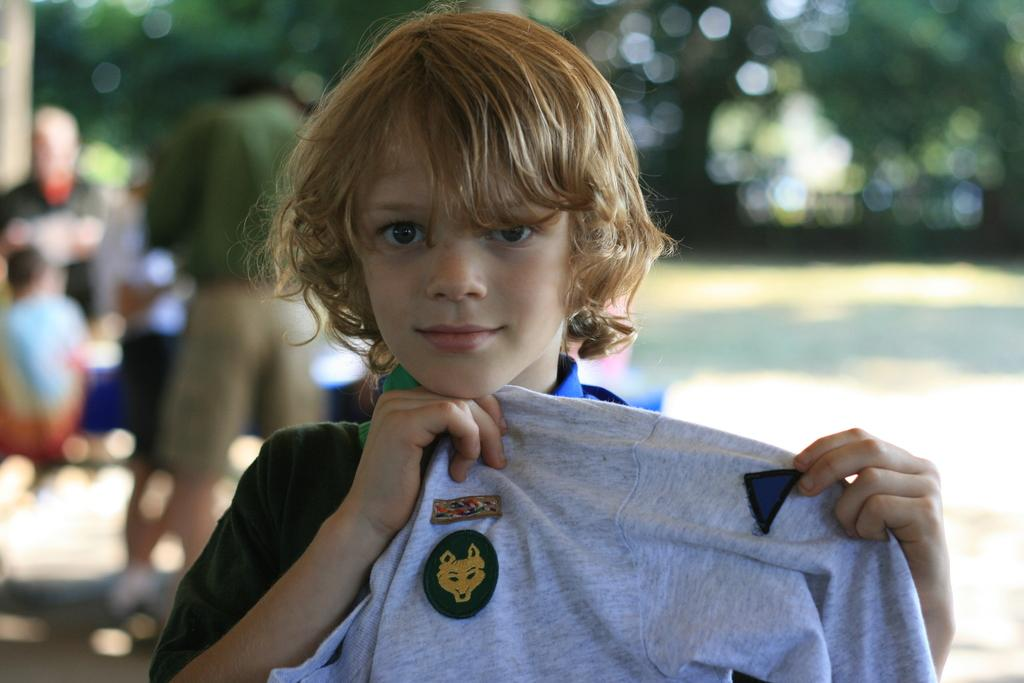What is the kid holding in the image? The kid is holding a cloth in the image. What can be seen in the background of the image? There are people standing and trees present in the background of the image. What is the temper of the kid's friends in the image? There is no information about the kid's friends or their temper in the image. 